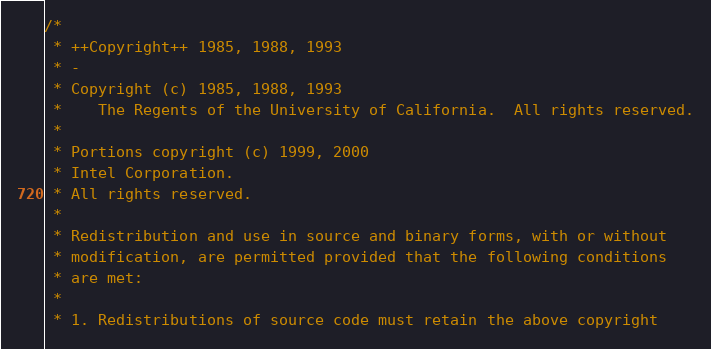<code> <loc_0><loc_0><loc_500><loc_500><_C_>/*
 * ++Copyright++ 1985, 1988, 1993
 * -
 * Copyright (c) 1985, 1988, 1993
 *    The Regents of the University of California.  All rights reserved.
 *
 * Portions copyright (c) 1999, 2000
 * Intel Corporation.
 * All rights reserved.
 * 
 * Redistribution and use in source and binary forms, with or without
 * modification, are permitted provided that the following conditions
 * are met:
 * 
 * 1. Redistributions of source code must retain the above copyright</code> 